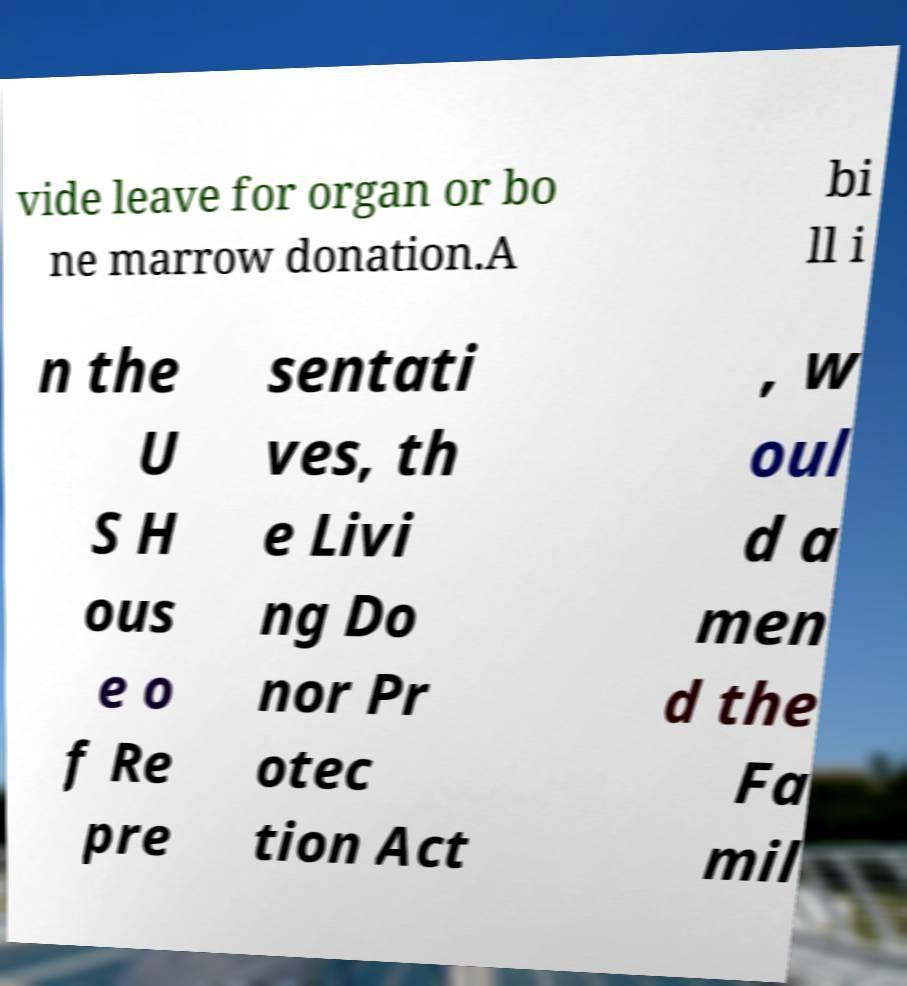Can you accurately transcribe the text from the provided image for me? vide leave for organ or bo ne marrow donation.A bi ll i n the U S H ous e o f Re pre sentati ves, th e Livi ng Do nor Pr otec tion Act , w oul d a men d the Fa mil 